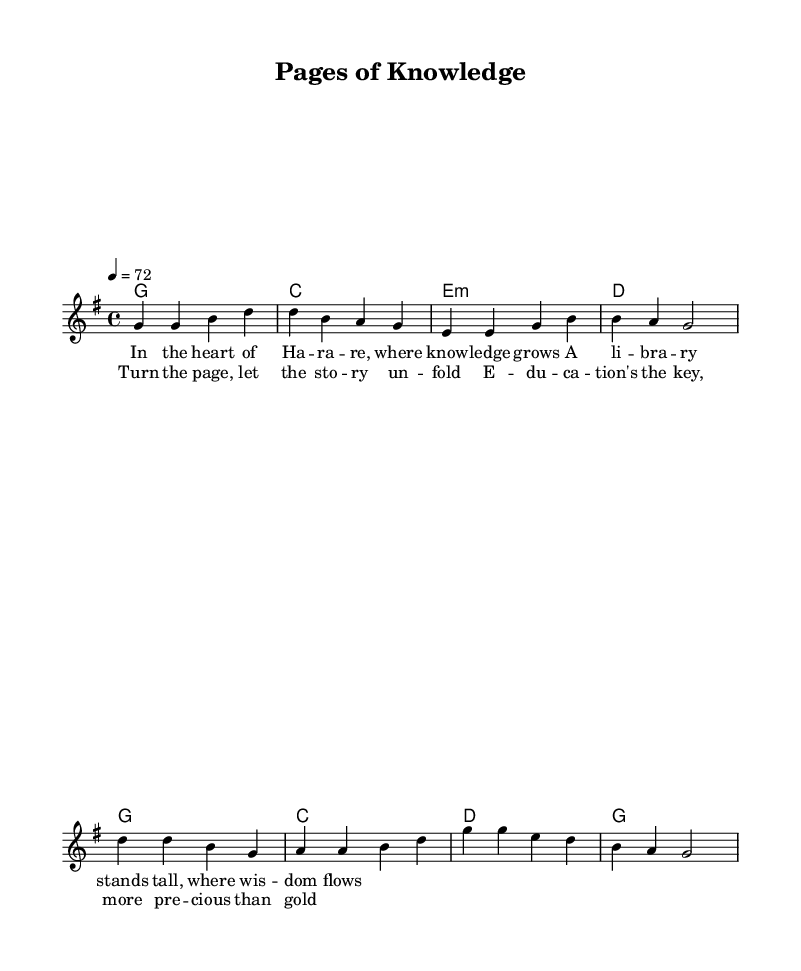What is the key signature of this music? The key signature is G major, which has one sharp (F#). We can identify this from the global settings at the start of the code, stating the key is set to G major.
Answer: G major What is the time signature of this music? The time signature is 4/4, indicating four beats per measure and a quarter note receives one beat. This is specified in the global settings section of the code.
Answer: 4/4 What is the tempo marking of the piece? The tempo marking is 72 beats per minute, as indicated by the tempo directive within the global settings. This means the piece should be played at a moderate speed.
Answer: 72 In the chorus, what is the first note? The first note of the chorus is D. We can see this from the melody line where the chorus starts, and the first note specified is the D note.
Answer: D What lyrical theme is presented in the chorus? The lyrical theme is about valuing education and knowledge. The lyrics mention turning the page and how education is precious. This indicates a celebration of learning as the central theme.
Answer: education How does the musical style of this piece relate to its theme? The country rock style is characterized by its storytelling lyrics and a blend of traditional country and rock elements. This aligns with the theme of education and literacy as storytelling is a crucial part of conveying knowledge.
Answer: storytelling 